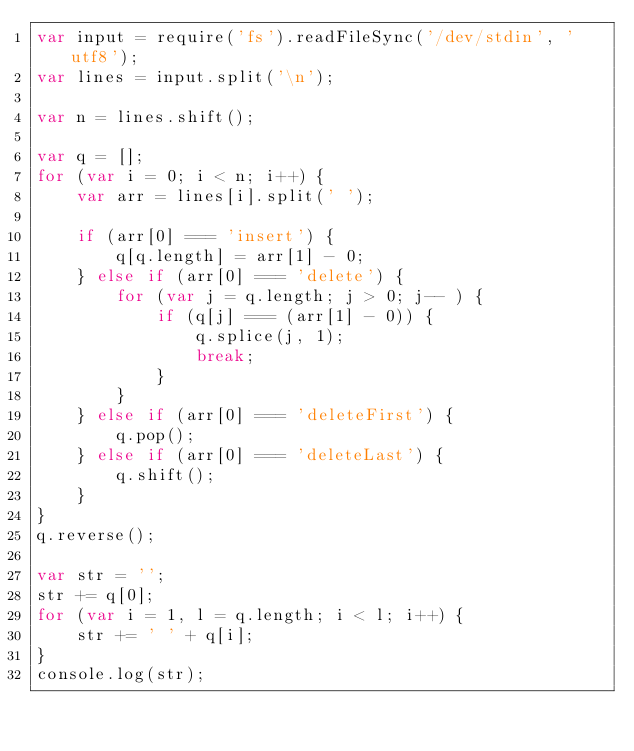<code> <loc_0><loc_0><loc_500><loc_500><_JavaScript_>var input = require('fs').readFileSync('/dev/stdin', 'utf8');
var lines = input.split('\n');

var n = lines.shift();

var q = [];
for (var i = 0; i < n; i++) {
	var arr = lines[i].split(' ');

	if (arr[0] === 'insert') {
		q[q.length] = arr[1] - 0;
	} else if (arr[0] === 'delete') {
		for (var j = q.length; j > 0; j-- ) {
			if (q[j] === (arr[1] - 0)) {
				q.splice(j, 1);
				break;
			}
		}
	} else if (arr[0] === 'deleteFirst') {
		q.pop();
	} else if (arr[0] === 'deleteLast') {
		q.shift();
	}
}
q.reverse();

var str = '';
str += q[0];
for (var i = 1, l = q.length; i < l; i++) {
	str += ' ' + q[i];
}
console.log(str);</code> 